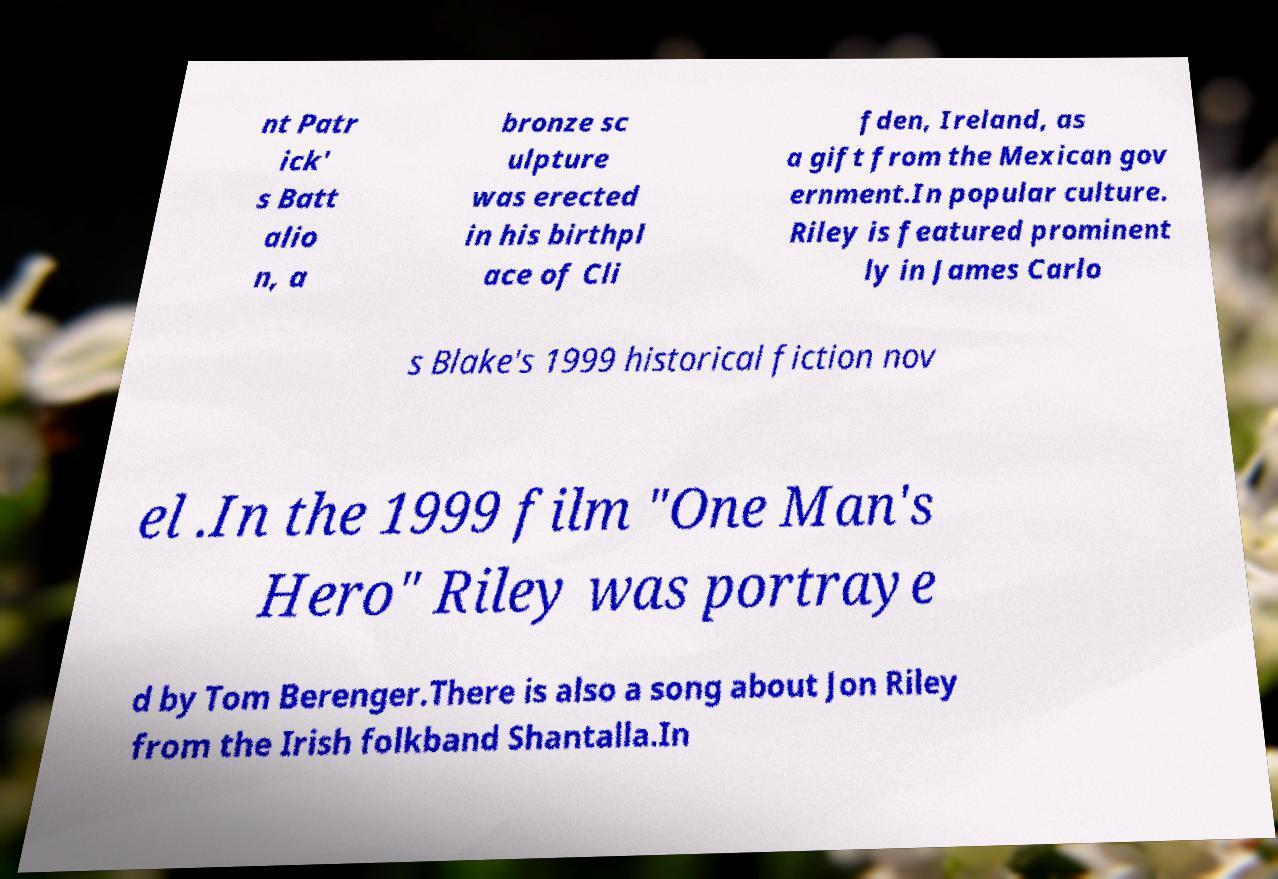There's text embedded in this image that I need extracted. Can you transcribe it verbatim? nt Patr ick' s Batt alio n, a bronze sc ulpture was erected in his birthpl ace of Cli fden, Ireland, as a gift from the Mexican gov ernment.In popular culture. Riley is featured prominent ly in James Carlo s Blake's 1999 historical fiction nov el .In the 1999 film "One Man's Hero" Riley was portraye d by Tom Berenger.There is also a song about Jon Riley from the Irish folkband Shantalla.In 